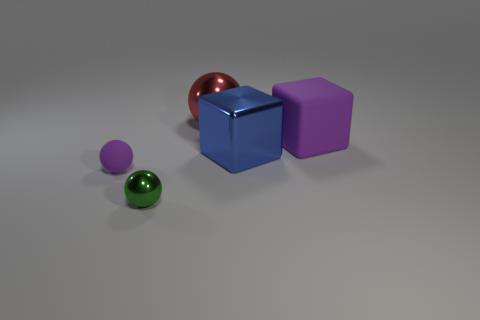The other tiny thing that is the same shape as the small purple object is what color? green 